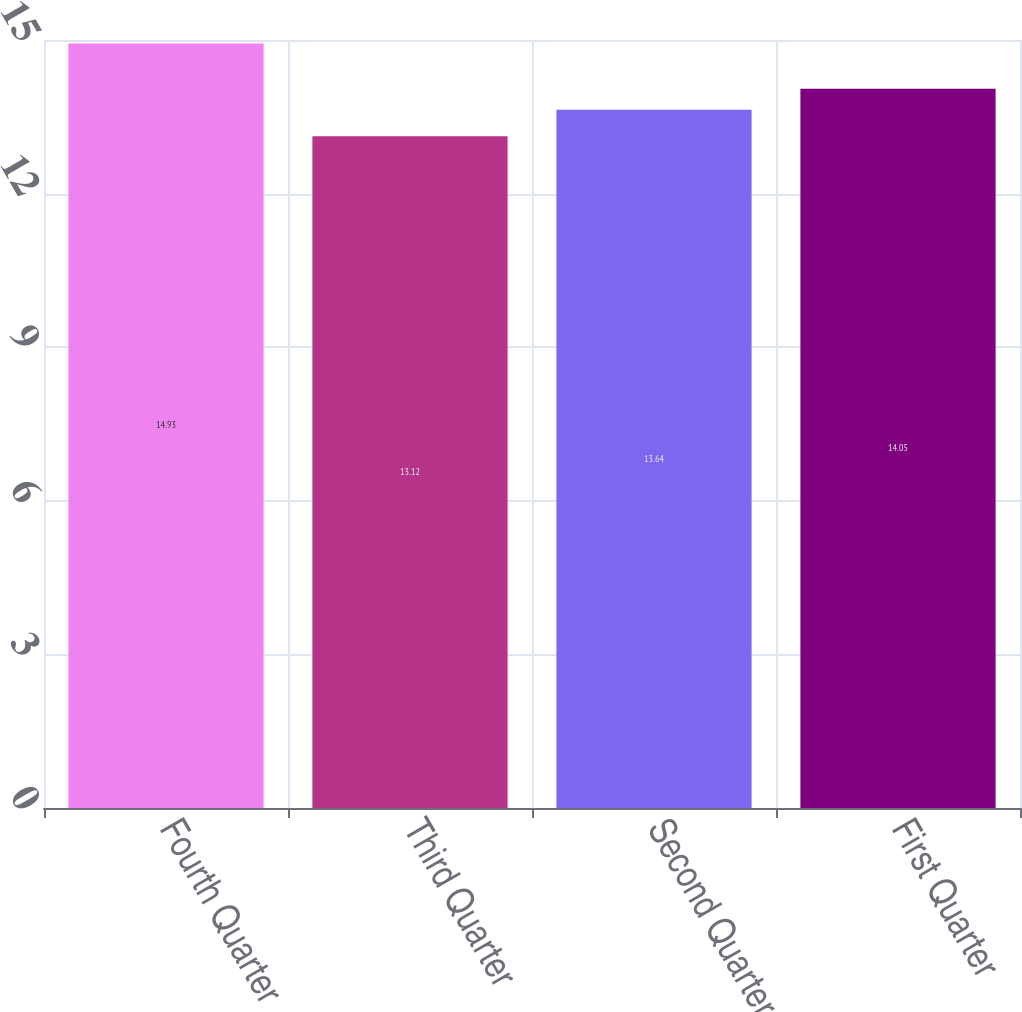Convert chart to OTSL. <chart><loc_0><loc_0><loc_500><loc_500><bar_chart><fcel>Fourth Quarter<fcel>Third Quarter<fcel>Second Quarter<fcel>First Quarter<nl><fcel>14.93<fcel>13.12<fcel>13.64<fcel>14.05<nl></chart> 